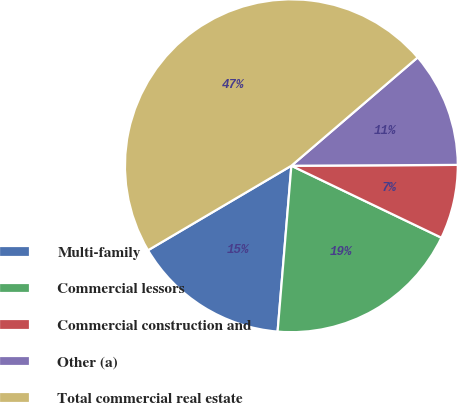Convert chart to OTSL. <chart><loc_0><loc_0><loc_500><loc_500><pie_chart><fcel>Multi-family<fcel>Commercial lessors<fcel>Commercial construction and<fcel>Other (a)<fcel>Total commercial real estate<nl><fcel>15.2%<fcel>19.2%<fcel>7.2%<fcel>11.2%<fcel>47.19%<nl></chart> 